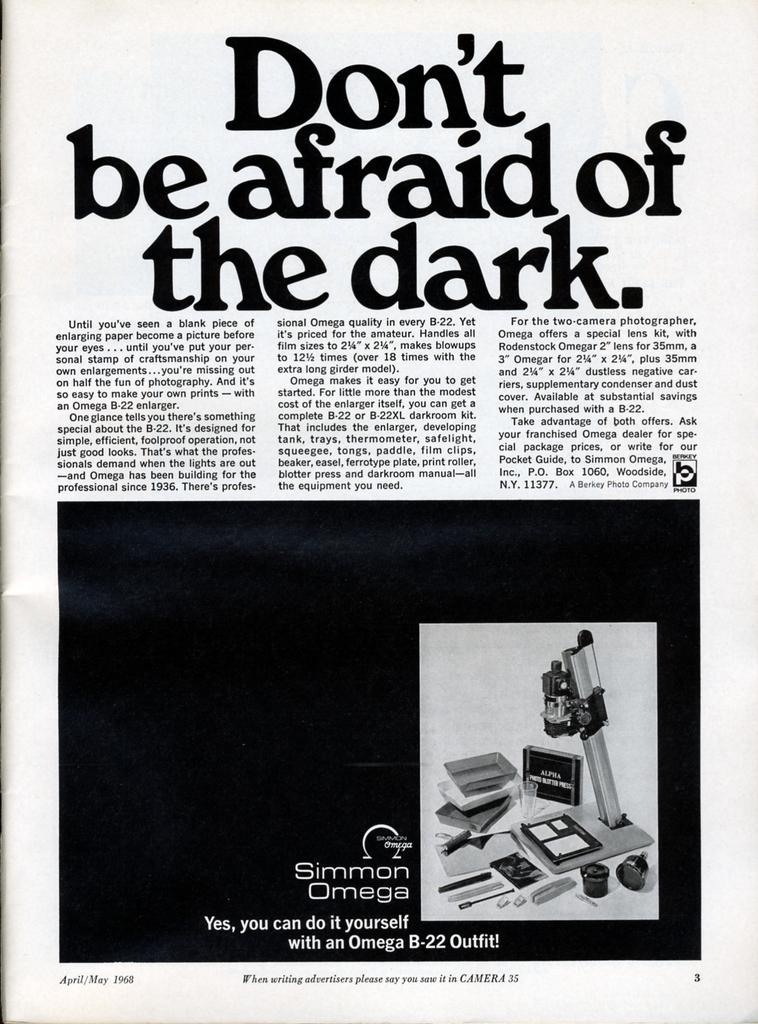Provide a one-sentence caption for the provided image. The passage is titled Don't be afraid of the dark. 